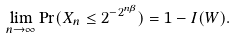<formula> <loc_0><loc_0><loc_500><loc_500>\lim _ { n \to \infty } \Pr ( X _ { n } \leq 2 ^ { - 2 ^ { n \beta } } ) = 1 - I ( W ) .</formula> 